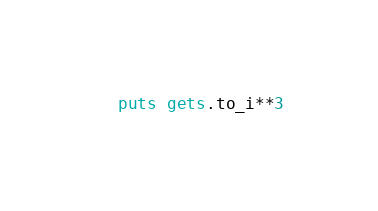<code> <loc_0><loc_0><loc_500><loc_500><_Ruby_>puts gets.to_i**3</code> 